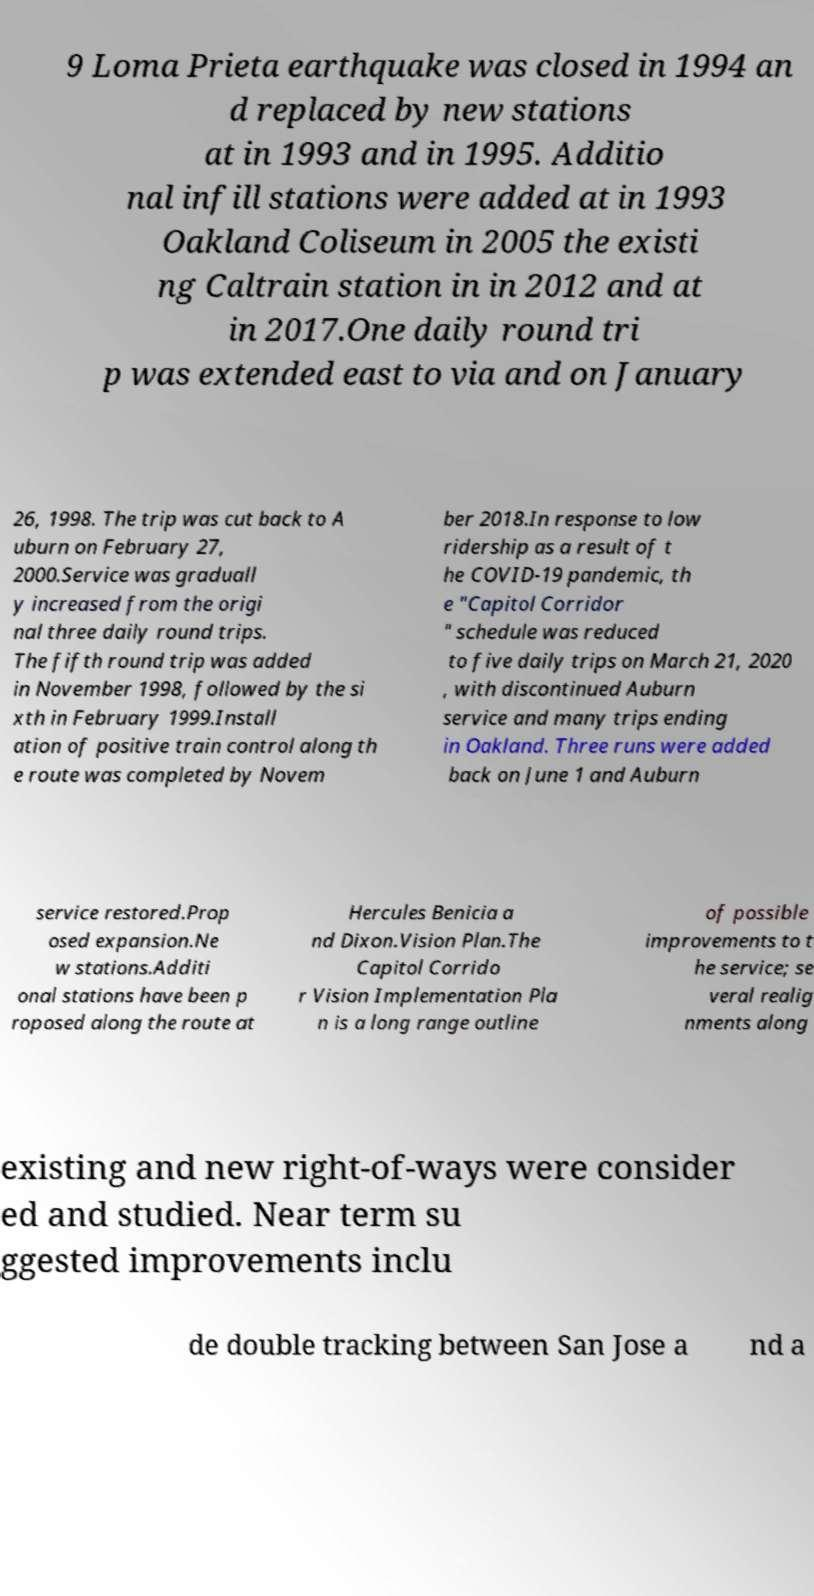Please read and relay the text visible in this image. What does it say? 9 Loma Prieta earthquake was closed in 1994 an d replaced by new stations at in 1993 and in 1995. Additio nal infill stations were added at in 1993 Oakland Coliseum in 2005 the existi ng Caltrain station in in 2012 and at in 2017.One daily round tri p was extended east to via and on January 26, 1998. The trip was cut back to A uburn on February 27, 2000.Service was graduall y increased from the origi nal three daily round trips. The fifth round trip was added in November 1998, followed by the si xth in February 1999.Install ation of positive train control along th e route was completed by Novem ber 2018.In response to low ridership as a result of t he COVID-19 pandemic, th e "Capitol Corridor " schedule was reduced to five daily trips on March 21, 2020 , with discontinued Auburn service and many trips ending in Oakland. Three runs were added back on June 1 and Auburn service restored.Prop osed expansion.Ne w stations.Additi onal stations have been p roposed along the route at Hercules Benicia a nd Dixon.Vision Plan.The Capitol Corrido r Vision Implementation Pla n is a long range outline of possible improvements to t he service; se veral realig nments along existing and new right-of-ways were consider ed and studied. Near term su ggested improvements inclu de double tracking between San Jose a nd a 